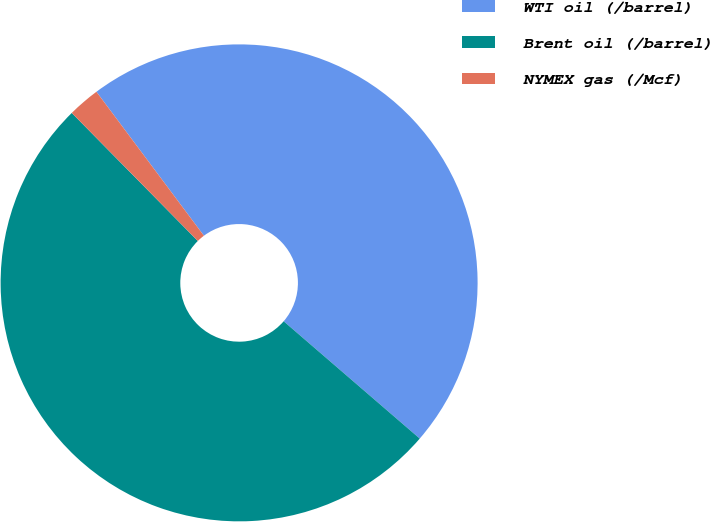Convert chart. <chart><loc_0><loc_0><loc_500><loc_500><pie_chart><fcel>WTI oil (/barrel)<fcel>Brent oil (/barrel)<fcel>NYMEX gas (/Mcf)<nl><fcel>46.53%<fcel>51.3%<fcel>2.17%<nl></chart> 